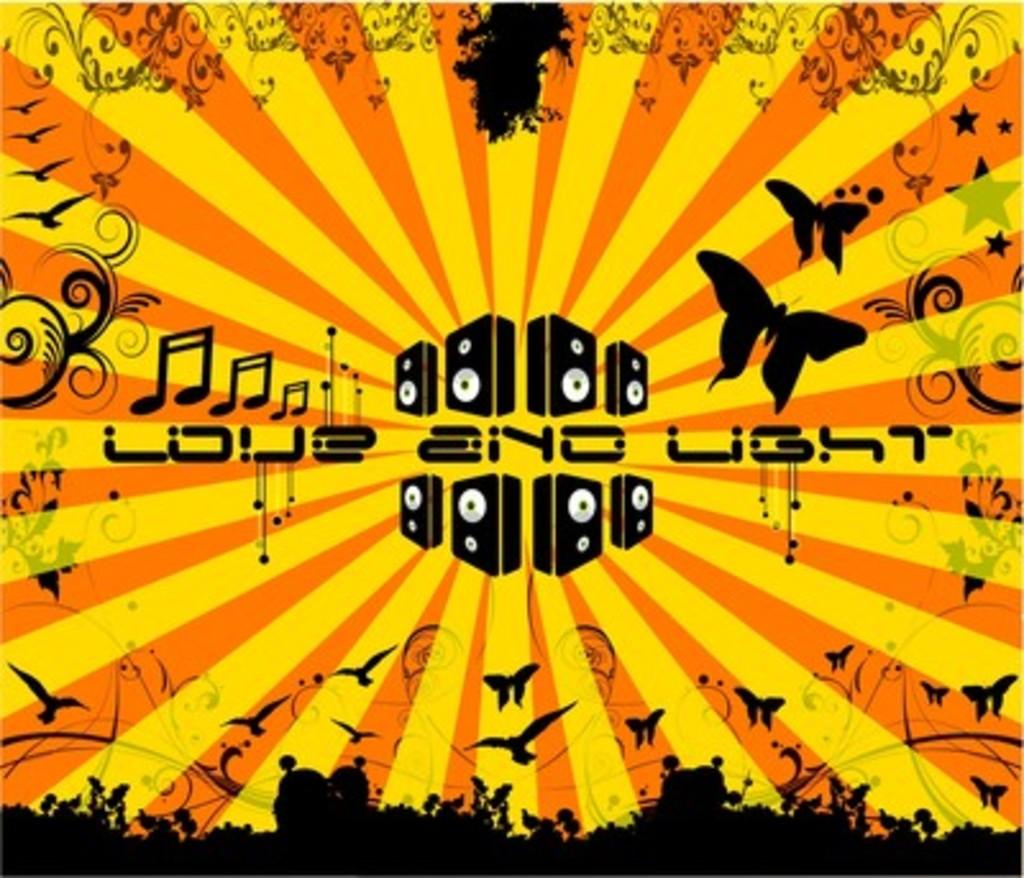What is written in the middle?
Give a very brief answer. Love and light. 